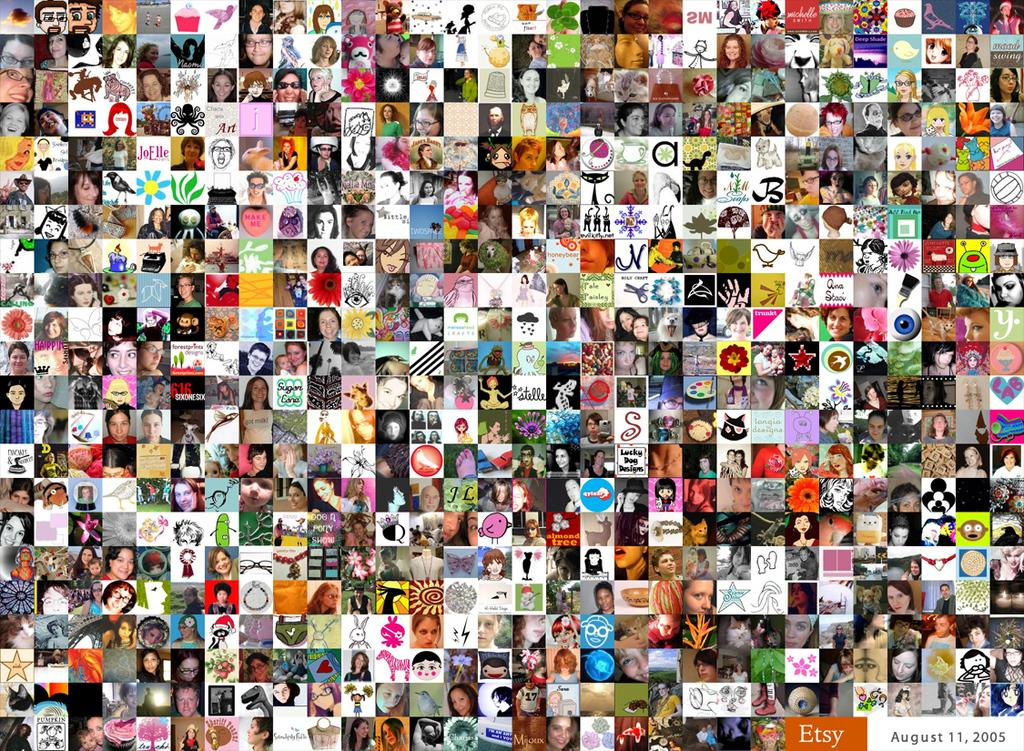What type of artwork is depicted in the image? The image is a collage. What types of elements can be found in the collage? There are faces, flowers, animals, toys, and various objects in the collage. Can you describe the overall appearance of the collage? The collage is colorful. How does the wind affect the cable in the image? There is no wind or cable present in the image; it is a collage featuring faces, flowers, animals, toys, and various objects. 